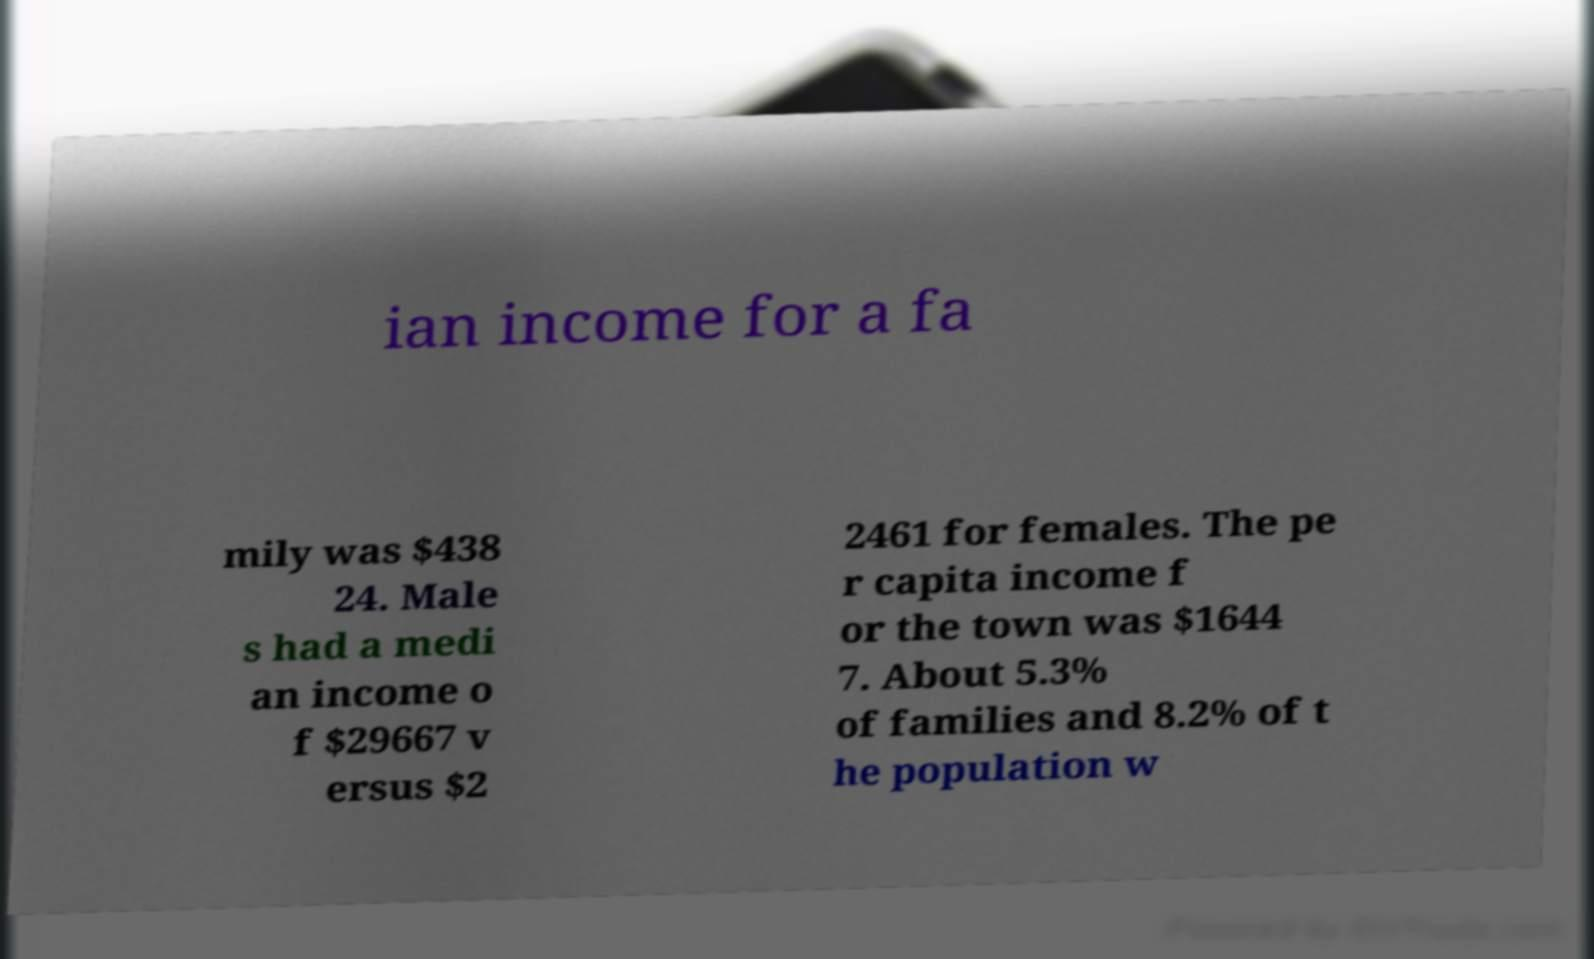There's text embedded in this image that I need extracted. Can you transcribe it verbatim? ian income for a fa mily was $438 24. Male s had a medi an income o f $29667 v ersus $2 2461 for females. The pe r capita income f or the town was $1644 7. About 5.3% of families and 8.2% of t he population w 